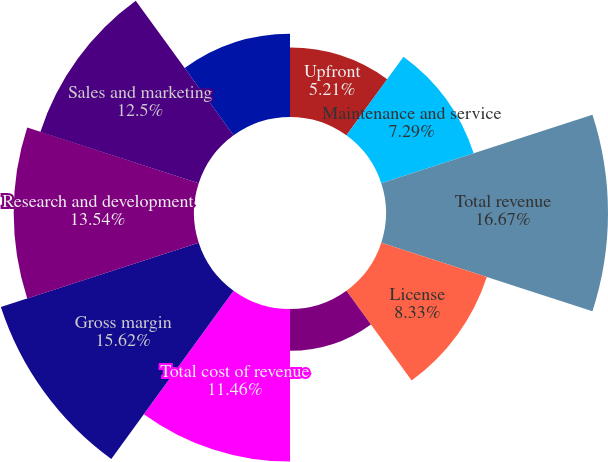Convert chart to OTSL. <chart><loc_0><loc_0><loc_500><loc_500><pie_chart><fcel>Upfront<fcel>Maintenance and service<fcel>Total revenue<fcel>License<fcel>Amortization of intangible<fcel>Total cost of revenue<fcel>Gross margin<fcel>Research and development<fcel>Sales and marketing<fcel>General and administrative<nl><fcel>5.21%<fcel>7.29%<fcel>16.67%<fcel>8.33%<fcel>3.13%<fcel>11.46%<fcel>15.62%<fcel>13.54%<fcel>12.5%<fcel>6.25%<nl></chart> 